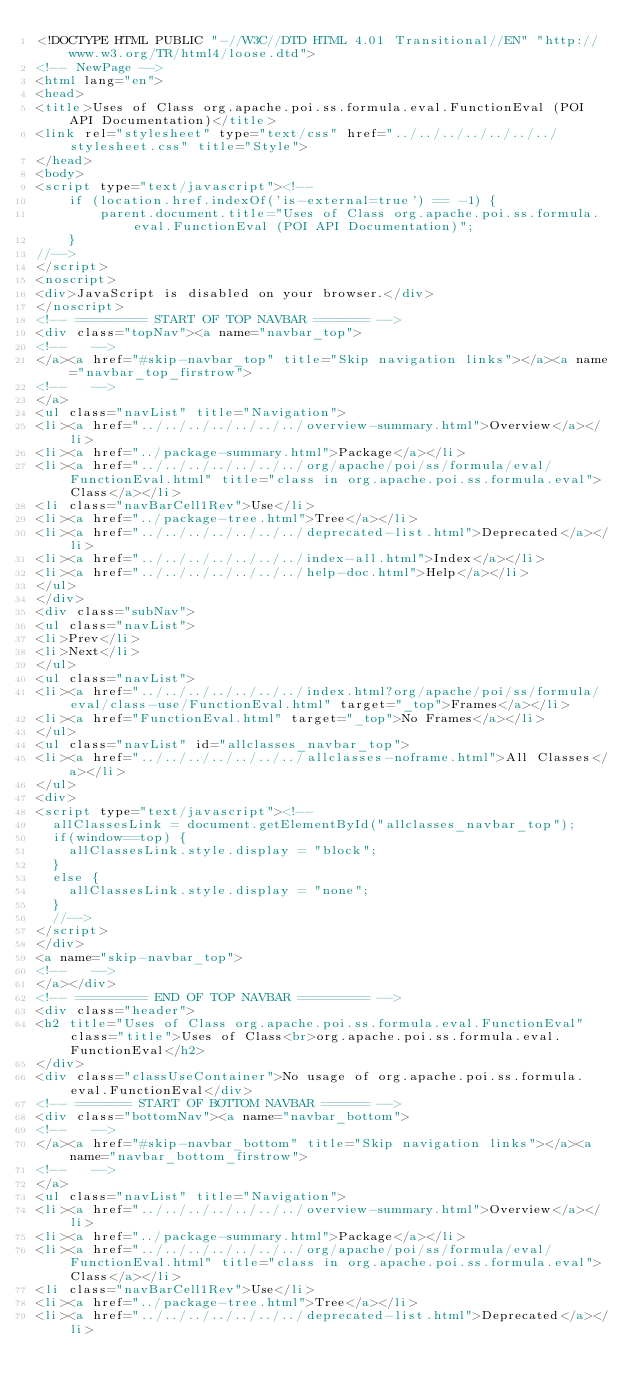Convert code to text. <code><loc_0><loc_0><loc_500><loc_500><_HTML_><!DOCTYPE HTML PUBLIC "-//W3C//DTD HTML 4.01 Transitional//EN" "http://www.w3.org/TR/html4/loose.dtd">
<!-- NewPage -->
<html lang="en">
<head>
<title>Uses of Class org.apache.poi.ss.formula.eval.FunctionEval (POI API Documentation)</title>
<link rel="stylesheet" type="text/css" href="../../../../../../../stylesheet.css" title="Style">
</head>
<body>
<script type="text/javascript"><!--
    if (location.href.indexOf('is-external=true') == -1) {
        parent.document.title="Uses of Class org.apache.poi.ss.formula.eval.FunctionEval (POI API Documentation)";
    }
//-->
</script>
<noscript>
<div>JavaScript is disabled on your browser.</div>
</noscript>
<!-- ========= START OF TOP NAVBAR ======= -->
<div class="topNav"><a name="navbar_top">
<!--   -->
</a><a href="#skip-navbar_top" title="Skip navigation links"></a><a name="navbar_top_firstrow">
<!--   -->
</a>
<ul class="navList" title="Navigation">
<li><a href="../../../../../../../overview-summary.html">Overview</a></li>
<li><a href="../package-summary.html">Package</a></li>
<li><a href="../../../../../../../org/apache/poi/ss/formula/eval/FunctionEval.html" title="class in org.apache.poi.ss.formula.eval">Class</a></li>
<li class="navBarCell1Rev">Use</li>
<li><a href="../package-tree.html">Tree</a></li>
<li><a href="../../../../../../../deprecated-list.html">Deprecated</a></li>
<li><a href="../../../../../../../index-all.html">Index</a></li>
<li><a href="../../../../../../../help-doc.html">Help</a></li>
</ul>
</div>
<div class="subNav">
<ul class="navList">
<li>Prev</li>
<li>Next</li>
</ul>
<ul class="navList">
<li><a href="../../../../../../../index.html?org/apache/poi/ss/formula/eval/class-use/FunctionEval.html" target="_top">Frames</a></li>
<li><a href="FunctionEval.html" target="_top">No Frames</a></li>
</ul>
<ul class="navList" id="allclasses_navbar_top">
<li><a href="../../../../../../../allclasses-noframe.html">All Classes</a></li>
</ul>
<div>
<script type="text/javascript"><!--
  allClassesLink = document.getElementById("allclasses_navbar_top");
  if(window==top) {
    allClassesLink.style.display = "block";
  }
  else {
    allClassesLink.style.display = "none";
  }
  //-->
</script>
</div>
<a name="skip-navbar_top">
<!--   -->
</a></div>
<!-- ========= END OF TOP NAVBAR ========= -->
<div class="header">
<h2 title="Uses of Class org.apache.poi.ss.formula.eval.FunctionEval" class="title">Uses of Class<br>org.apache.poi.ss.formula.eval.FunctionEval</h2>
</div>
<div class="classUseContainer">No usage of org.apache.poi.ss.formula.eval.FunctionEval</div>
<!-- ======= START OF BOTTOM NAVBAR ====== -->
<div class="bottomNav"><a name="navbar_bottom">
<!--   -->
</a><a href="#skip-navbar_bottom" title="Skip navigation links"></a><a name="navbar_bottom_firstrow">
<!--   -->
</a>
<ul class="navList" title="Navigation">
<li><a href="../../../../../../../overview-summary.html">Overview</a></li>
<li><a href="../package-summary.html">Package</a></li>
<li><a href="../../../../../../../org/apache/poi/ss/formula/eval/FunctionEval.html" title="class in org.apache.poi.ss.formula.eval">Class</a></li>
<li class="navBarCell1Rev">Use</li>
<li><a href="../package-tree.html">Tree</a></li>
<li><a href="../../../../../../../deprecated-list.html">Deprecated</a></li></code> 